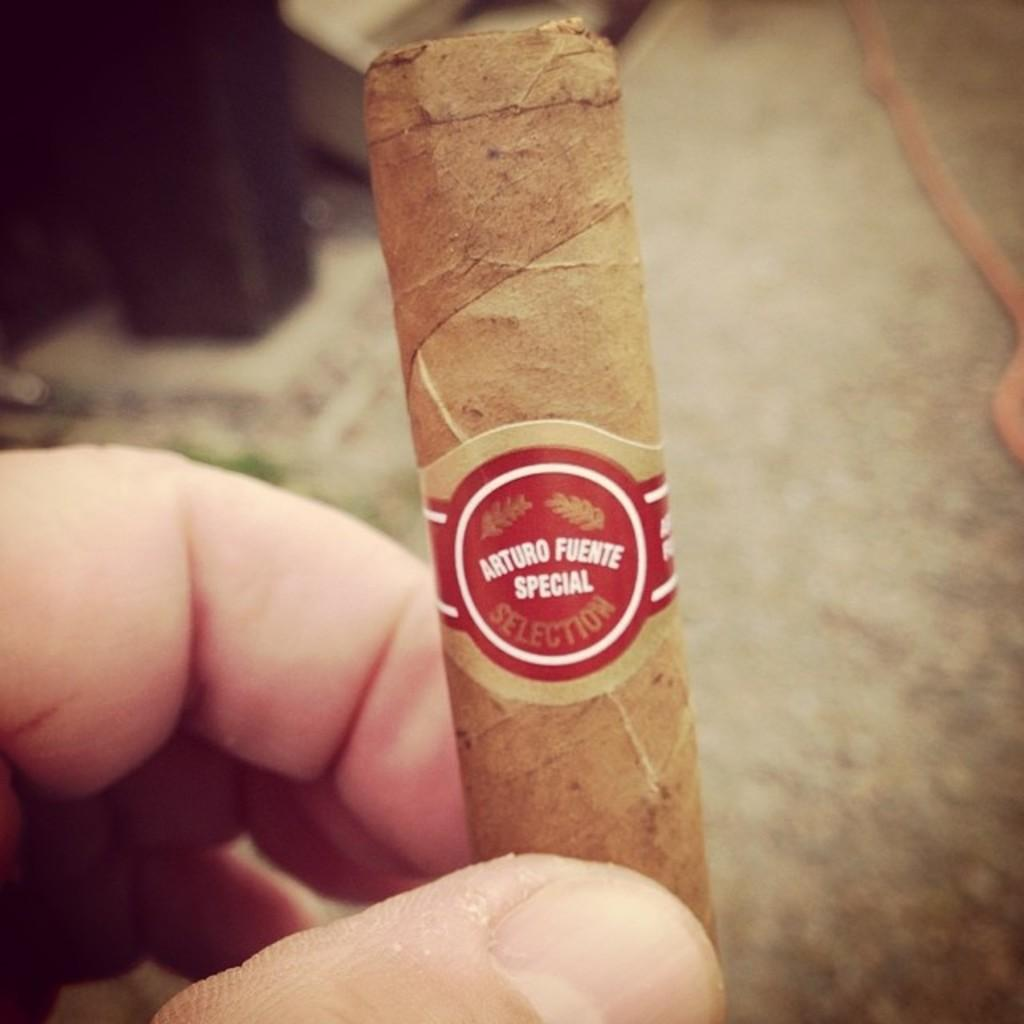What object is being held by the person in the image? There is a cigarette in the hand of a person in the image. Can you describe the background of the image? The background of the image is blurred. What type of unit is being harvested in the plantation visible in the image? There is no plantation or any type of unit visible in the image; it only features a person holding a cigarette with a blurred background. 